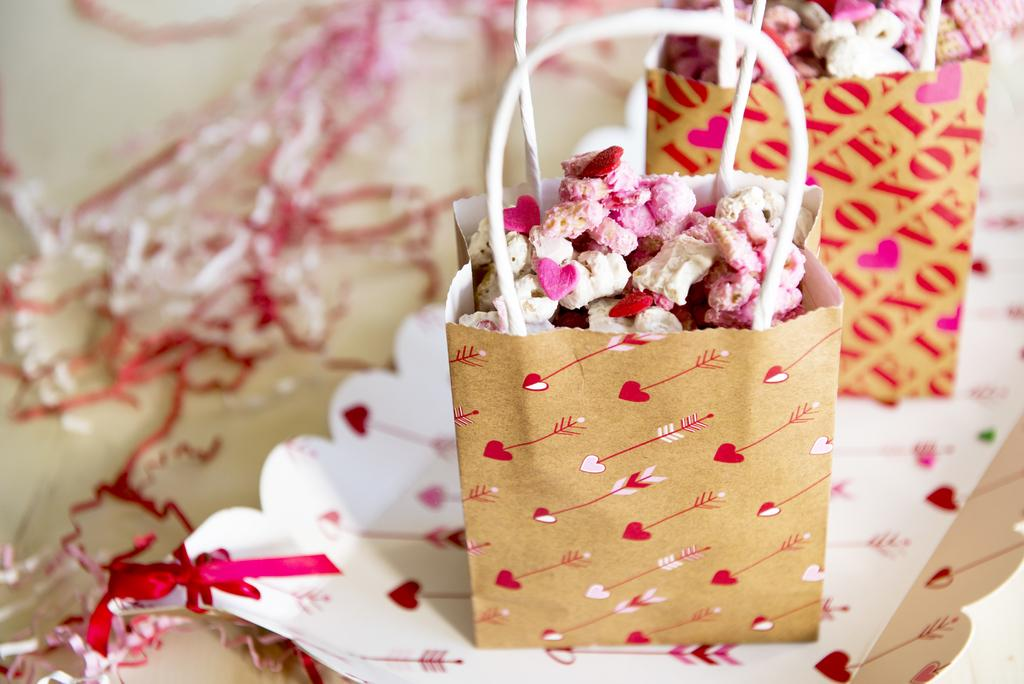What can be found inside the bags in the image? There are objects in the bags. What is located at the bottom of the image? There are decorative papers at the bottom of the image. How many mice can be seen playing basketball in the image? There are no mice or basketball present in the image. What type of pet is visible in the image? There is no pet visible in the image. 